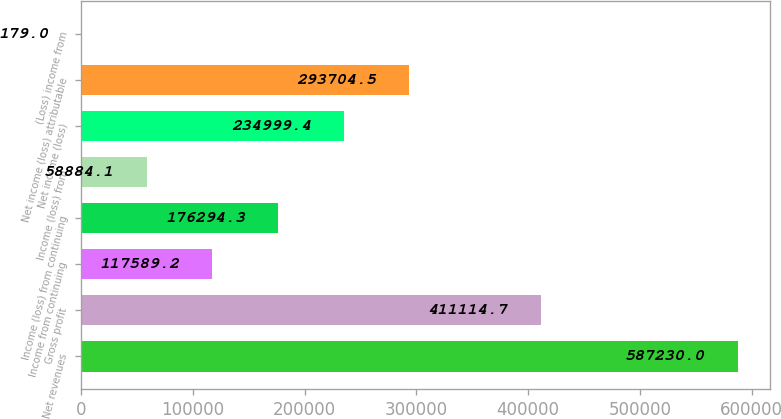Convert chart to OTSL. <chart><loc_0><loc_0><loc_500><loc_500><bar_chart><fcel>Net revenues<fcel>Gross profit<fcel>Income from continuing<fcel>Income (loss) from continuing<fcel>Income (loss) from<fcel>Net income (loss)<fcel>Net income (loss) attributable<fcel>(Loss) income from<nl><fcel>587230<fcel>411115<fcel>117589<fcel>176294<fcel>58884.1<fcel>234999<fcel>293704<fcel>179<nl></chart> 